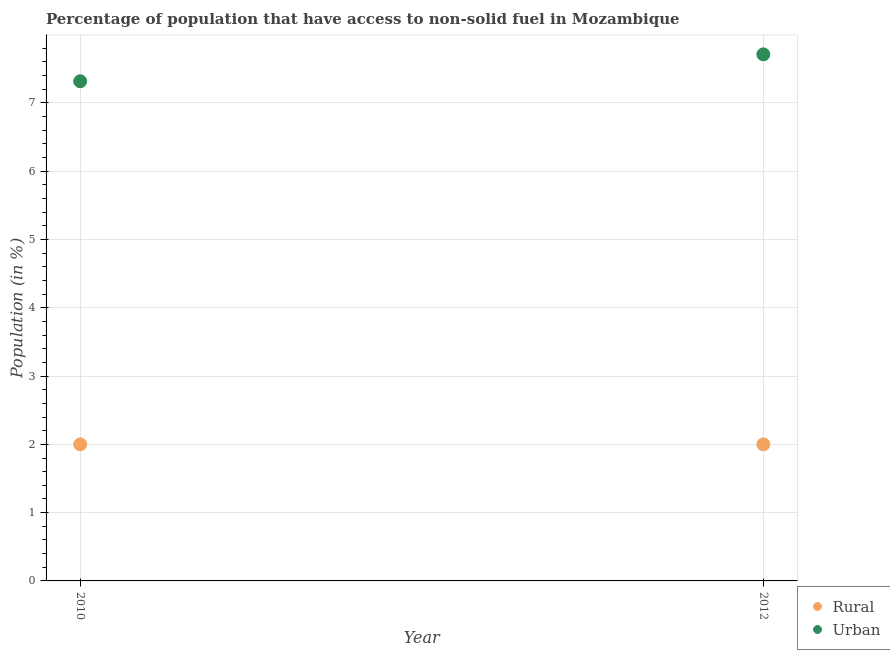How many different coloured dotlines are there?
Make the answer very short. 2. What is the rural population in 2012?
Your response must be concise. 2. Across all years, what is the maximum urban population?
Keep it short and to the point. 7.71. Across all years, what is the minimum rural population?
Provide a short and direct response. 2. In which year was the urban population minimum?
Provide a short and direct response. 2010. What is the total urban population in the graph?
Keep it short and to the point. 15.03. What is the difference between the urban population in 2010 and that in 2012?
Offer a terse response. -0.39. What is the difference between the urban population in 2010 and the rural population in 2012?
Offer a terse response. 5.32. What is the average urban population per year?
Keep it short and to the point. 7.51. In the year 2010, what is the difference between the rural population and urban population?
Keep it short and to the point. -5.32. What is the ratio of the urban population in 2010 to that in 2012?
Make the answer very short. 0.95. Does the rural population monotonically increase over the years?
Offer a very short reply. No. Is the rural population strictly greater than the urban population over the years?
Your answer should be compact. No. Is the urban population strictly less than the rural population over the years?
Your answer should be compact. No. How many dotlines are there?
Ensure brevity in your answer.  2. Are the values on the major ticks of Y-axis written in scientific E-notation?
Make the answer very short. No. Where does the legend appear in the graph?
Provide a succinct answer. Bottom right. How many legend labels are there?
Provide a short and direct response. 2. How are the legend labels stacked?
Your response must be concise. Vertical. What is the title of the graph?
Your answer should be compact. Percentage of population that have access to non-solid fuel in Mozambique. What is the Population (in %) in Rural in 2010?
Provide a short and direct response. 2. What is the Population (in %) in Urban in 2010?
Your response must be concise. 7.32. What is the Population (in %) in Rural in 2012?
Provide a short and direct response. 2. What is the Population (in %) of Urban in 2012?
Ensure brevity in your answer.  7.71. Across all years, what is the maximum Population (in %) in Rural?
Your answer should be very brief. 2. Across all years, what is the maximum Population (in %) in Urban?
Provide a short and direct response. 7.71. Across all years, what is the minimum Population (in %) in Rural?
Give a very brief answer. 2. Across all years, what is the minimum Population (in %) of Urban?
Offer a very short reply. 7.32. What is the total Population (in %) in Rural in the graph?
Provide a short and direct response. 4. What is the total Population (in %) in Urban in the graph?
Your answer should be compact. 15.03. What is the difference between the Population (in %) in Rural in 2010 and that in 2012?
Your answer should be very brief. 0. What is the difference between the Population (in %) of Urban in 2010 and that in 2012?
Provide a succinct answer. -0.39. What is the difference between the Population (in %) in Rural in 2010 and the Population (in %) in Urban in 2012?
Your answer should be compact. -5.71. What is the average Population (in %) in Rural per year?
Provide a succinct answer. 2. What is the average Population (in %) of Urban per year?
Provide a succinct answer. 7.51. In the year 2010, what is the difference between the Population (in %) in Rural and Population (in %) in Urban?
Offer a very short reply. -5.32. In the year 2012, what is the difference between the Population (in %) of Rural and Population (in %) of Urban?
Give a very brief answer. -5.71. What is the ratio of the Population (in %) of Urban in 2010 to that in 2012?
Make the answer very short. 0.95. What is the difference between the highest and the second highest Population (in %) in Urban?
Keep it short and to the point. 0.39. What is the difference between the highest and the lowest Population (in %) in Urban?
Your response must be concise. 0.39. 